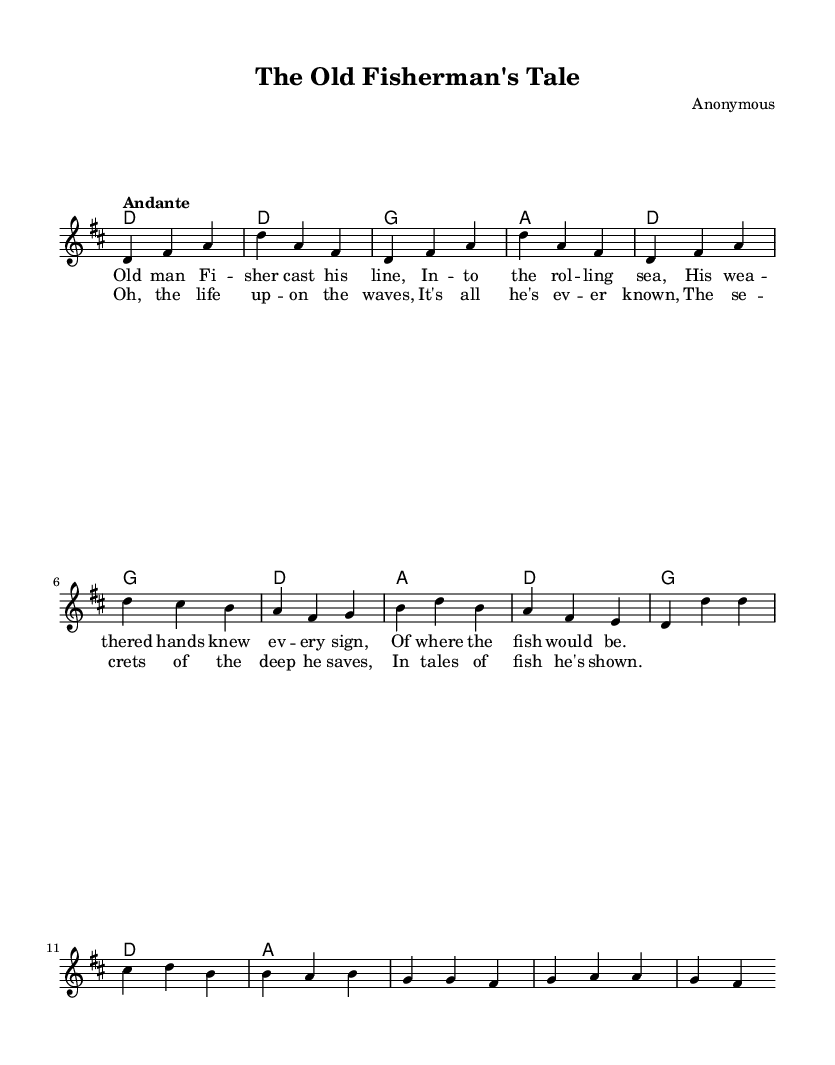What is the key signature of this music? The key signature is indicated by the sharps or flats at the beginning of the staff. In this case, there are two sharps: F# and C#, which identifies it as D major.
Answer: D major What is the time signature of this music? The time signature is shown at the beginning and indicates how many beats are in each measure. Here, the time signature is 3/4, meaning there are three beats per measure.
Answer: 3/4 What is the tempo marking for this piece? The tempo marking is noted at the beginning of the score, typically in Italian. It indicates the speed of the piece. Here, "Andante" suggests a moderate walking pace.
Answer: Andante How many measures are there in the chorus? To find the number of measures in the chorus, we can count the measures in the section labeled as the chorus. There are four measures visible in this part of the sheet music.
Answer: 4 What instruments are indicated in this score? The score specifies different staves for the melodic line and chords. There are no specific instrument names, but it appears set for guitar or piano accompanying a voice. Thus, it often suggests guitar or piano accompaniment.
Answer: Guitar/Piano What story does the lyrics of this song convey? By reading the lyrics, we can gather that the song tells a tale of an old fisherman and his experiences, exploring themes of wisdom, life on the water, and a connection to the ocean.
Answer: Fisherman's life 